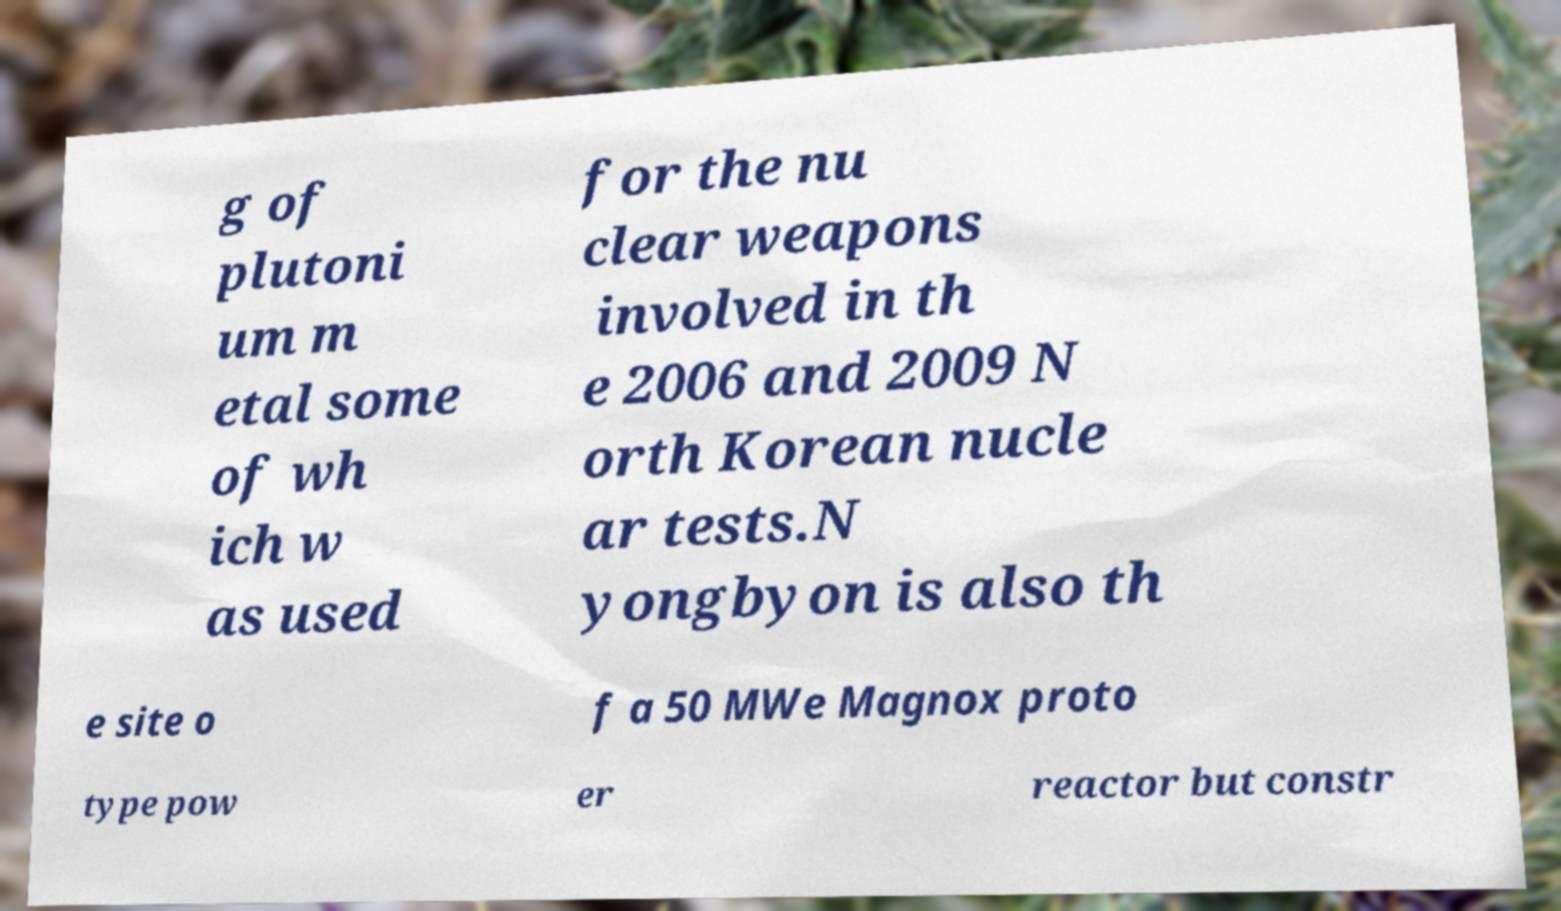Can you accurately transcribe the text from the provided image for me? g of plutoni um m etal some of wh ich w as used for the nu clear weapons involved in th e 2006 and 2009 N orth Korean nucle ar tests.N yongbyon is also th e site o f a 50 MWe Magnox proto type pow er reactor but constr 